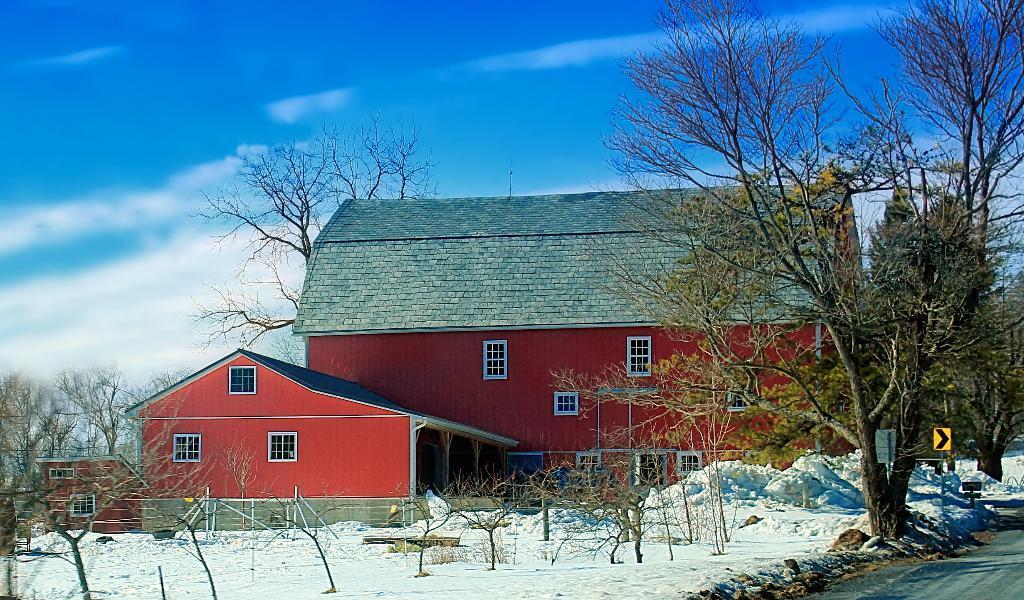Describe this image in one or two sentences. In this image we can see a few houses, there are windows, poles, sign boards, pillars, trees and snow, in the background we can see the sky. 